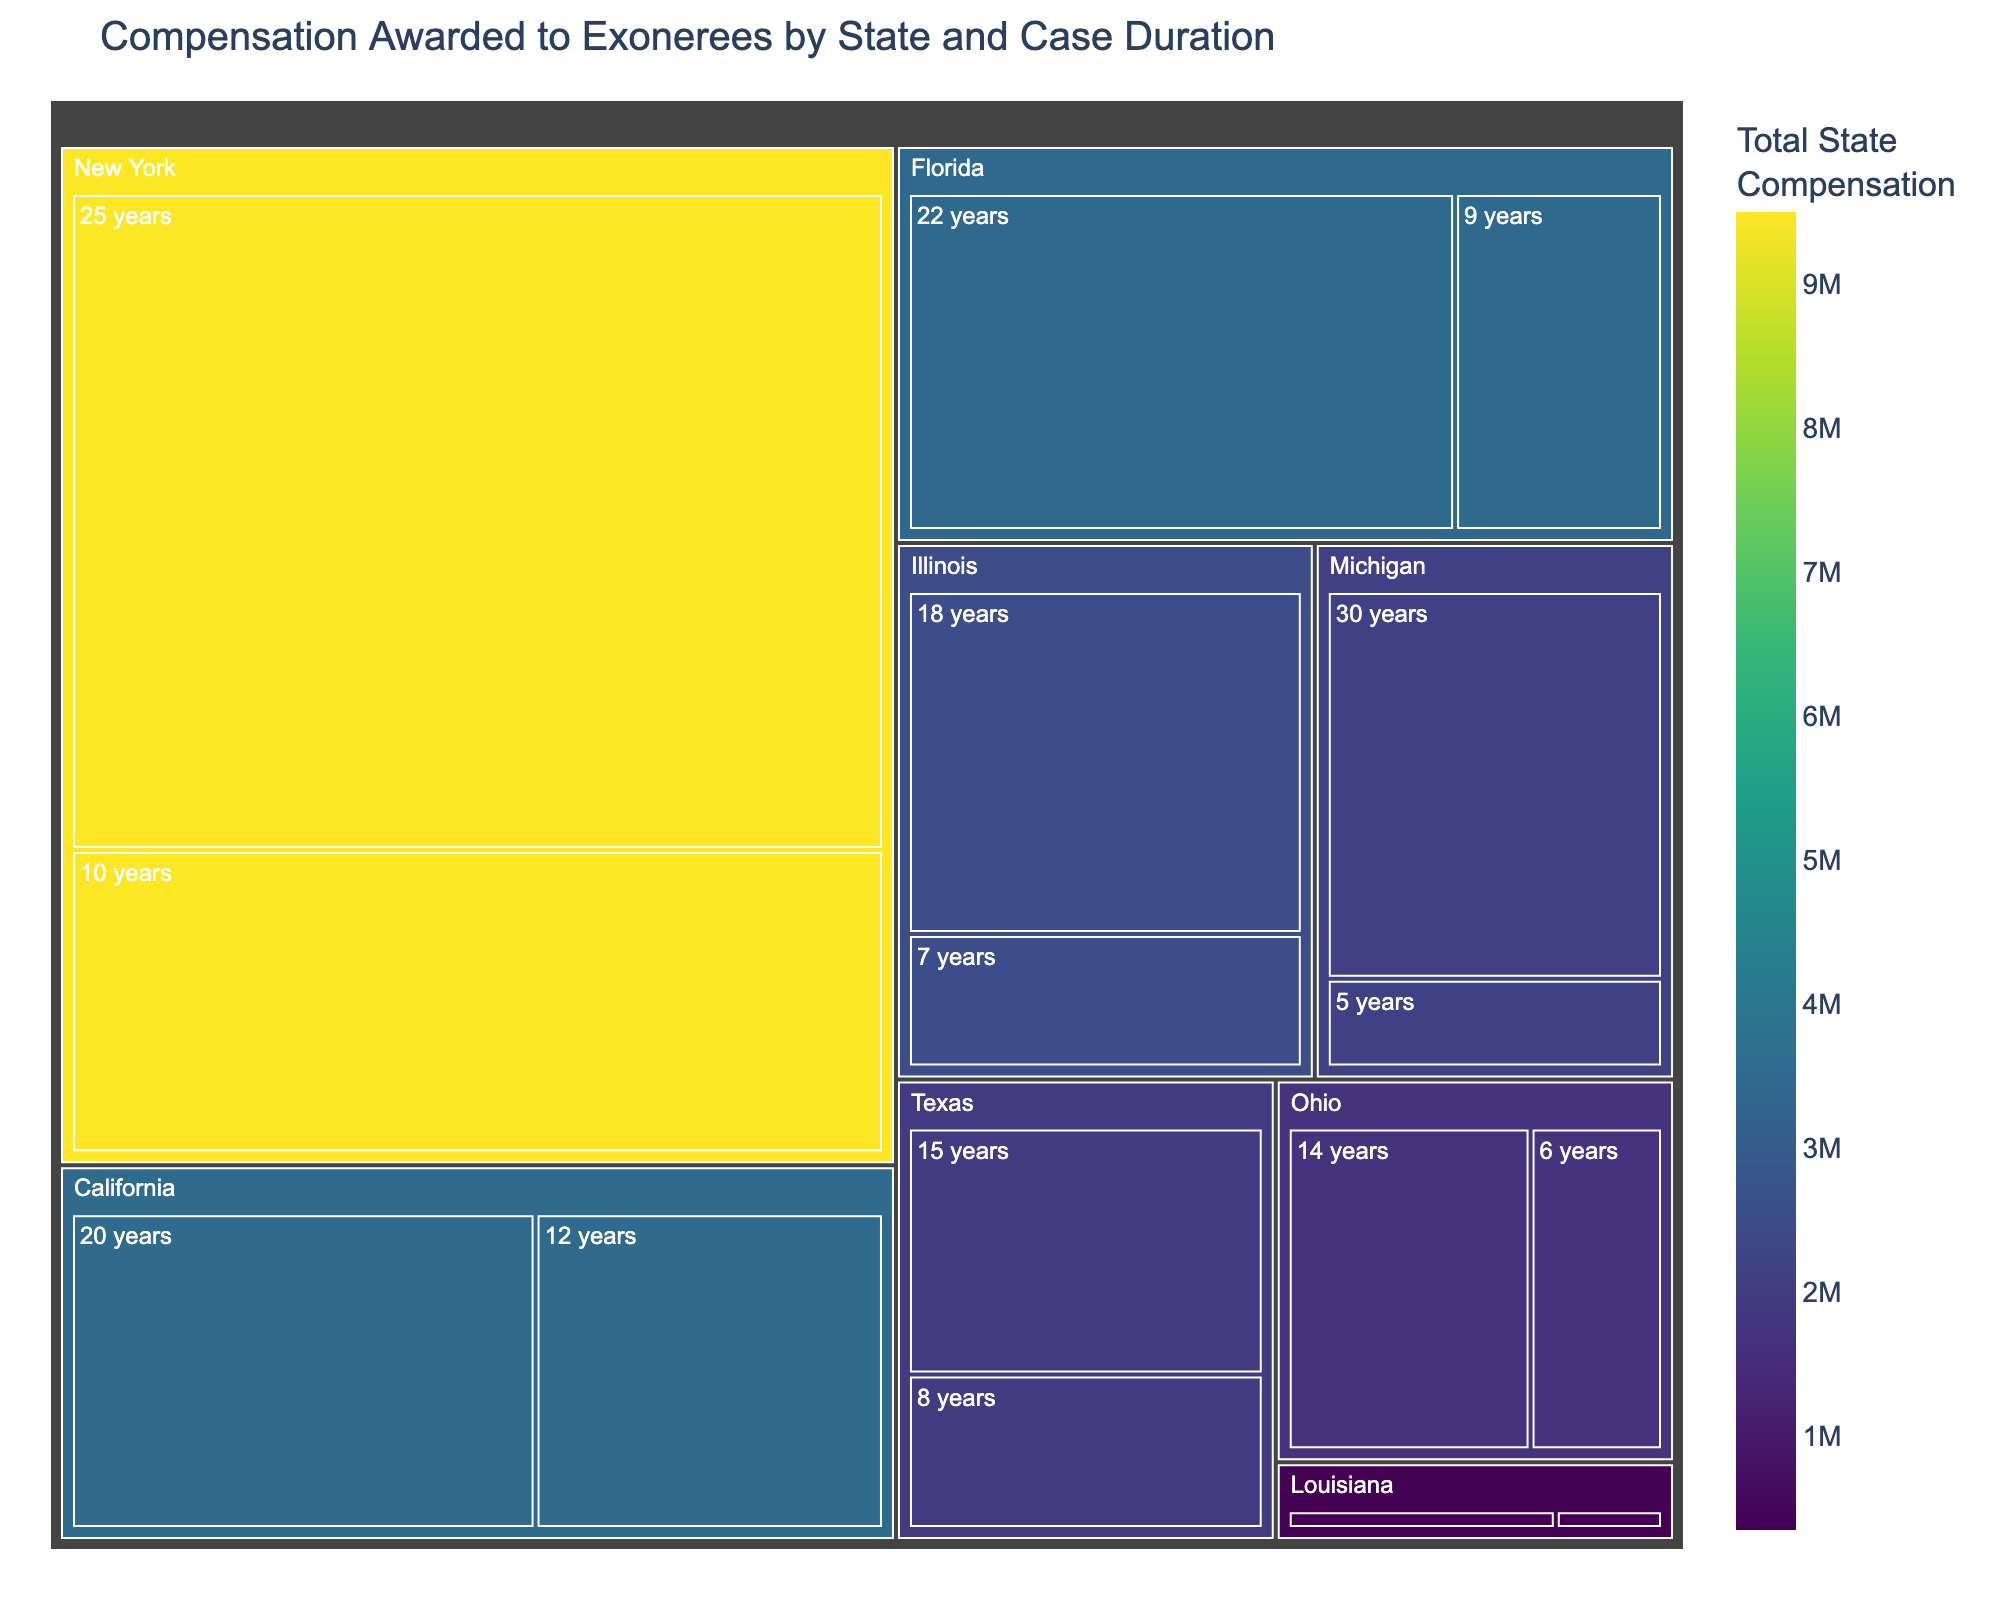What is the title of the treemap? The title of the treemap can usually be found at the top center of the figure. By reading the title from the provided image, we can clearly see it.
Answer: Compensation Awarded to Exonerees by State and Case Duration Which state has the highest total compensation awarded? The treemap uses colors and size to indicate total compensation. The state with the largest and darkest section represents the highest total compensation.
Answer: New York How many years was the shortest case duration in Texas? By locating Texas in the treemap and observing the duration labels within its section, we can identify the shortest duration.
Answer: 8 years Which state awarded the least amount of compensation for a single case? The smallest segmented square in the treemap by compensation amount across all states shows the least award for a single case.
Answer: Louisiana ($100,000) What is the combined compensation for exonerees in California? Locate California in the treemap and sum the compensation amounts for each duration listed under California.
Answer: $3,500,000 What is the average compensation for cases in Florida? Locate Florida, add up all the compensations, and divide by the number of cases in Florida. Calculation needed: ($2,500,000 + $950,000) / 2
Answer: $1,725,000 Compare the compensation for the longest case durations in Michigan and Ohio. Which state awarded more? Identify the longest durations in Michigan and Ohio, then compare the compensation amounts for those durations directly from the figure.
Answer: Michigan ($1,750,000) vs. Ohio ($1,100,000) Michigan How much more did exonerees in New York receive compared to Texas in total? Find the total compensation for New York and Texas, then subtract the Texas total from the New York total. New York total: $9,500,000, Texas total: $1,950,000
Answer: $7,550,000 Which case duration received the smallest compensation in the entire dataset? Scan the treemap for the smallest single compensation segment, considering all states, to identify this case.
Answer: Louisiana, 4 years ($100,000) How does the compensation for 10-year cases compare between Florida and New York? Locate the segments for 10-year cases in both Florida and New York, then directly compare their compensation amounts.
Answer: Florida does not have a 10-year case listed, New York: $3,000,000 